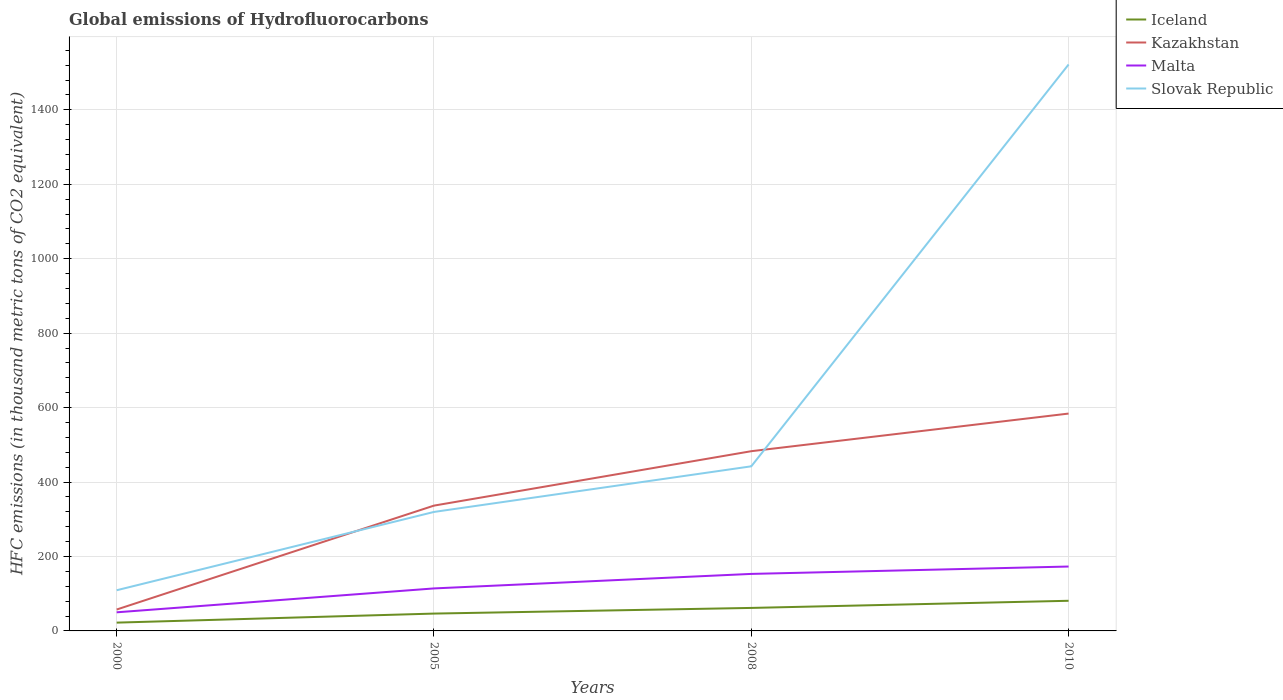Is the number of lines equal to the number of legend labels?
Give a very brief answer. Yes. Across all years, what is the maximum global emissions of Hydrofluorocarbons in Slovak Republic?
Your answer should be very brief. 109.3. What is the total global emissions of Hydrofluorocarbons in Malta in the graph?
Your answer should be compact. -39. What is the difference between the highest and the second highest global emissions of Hydrofluorocarbons in Malta?
Ensure brevity in your answer.  123. What is the difference between the highest and the lowest global emissions of Hydrofluorocarbons in Malta?
Make the answer very short. 2. How many lines are there?
Your answer should be very brief. 4. How many years are there in the graph?
Offer a terse response. 4. What is the difference between two consecutive major ticks on the Y-axis?
Your answer should be compact. 200. Are the values on the major ticks of Y-axis written in scientific E-notation?
Give a very brief answer. No. Where does the legend appear in the graph?
Give a very brief answer. Top right. How many legend labels are there?
Provide a short and direct response. 4. What is the title of the graph?
Offer a terse response. Global emissions of Hydrofluorocarbons. What is the label or title of the X-axis?
Your answer should be compact. Years. What is the label or title of the Y-axis?
Provide a succinct answer. HFC emissions (in thousand metric tons of CO2 equivalent). What is the HFC emissions (in thousand metric tons of CO2 equivalent) in Iceland in 2000?
Your answer should be compact. 22.3. What is the HFC emissions (in thousand metric tons of CO2 equivalent) of Kazakhstan in 2000?
Offer a terse response. 57.5. What is the HFC emissions (in thousand metric tons of CO2 equivalent) in Malta in 2000?
Offer a terse response. 50. What is the HFC emissions (in thousand metric tons of CO2 equivalent) in Slovak Republic in 2000?
Give a very brief answer. 109.3. What is the HFC emissions (in thousand metric tons of CO2 equivalent) of Iceland in 2005?
Offer a terse response. 46.6. What is the HFC emissions (in thousand metric tons of CO2 equivalent) in Kazakhstan in 2005?
Offer a terse response. 336.7. What is the HFC emissions (in thousand metric tons of CO2 equivalent) in Malta in 2005?
Your response must be concise. 114.2. What is the HFC emissions (in thousand metric tons of CO2 equivalent) of Slovak Republic in 2005?
Your answer should be compact. 319.7. What is the HFC emissions (in thousand metric tons of CO2 equivalent) in Iceland in 2008?
Make the answer very short. 61.8. What is the HFC emissions (in thousand metric tons of CO2 equivalent) of Kazakhstan in 2008?
Give a very brief answer. 482.9. What is the HFC emissions (in thousand metric tons of CO2 equivalent) of Malta in 2008?
Your answer should be very brief. 153.2. What is the HFC emissions (in thousand metric tons of CO2 equivalent) of Slovak Republic in 2008?
Provide a succinct answer. 442.3. What is the HFC emissions (in thousand metric tons of CO2 equivalent) in Kazakhstan in 2010?
Provide a short and direct response. 584. What is the HFC emissions (in thousand metric tons of CO2 equivalent) in Malta in 2010?
Offer a terse response. 173. What is the HFC emissions (in thousand metric tons of CO2 equivalent) of Slovak Republic in 2010?
Offer a terse response. 1522. Across all years, what is the maximum HFC emissions (in thousand metric tons of CO2 equivalent) in Kazakhstan?
Offer a very short reply. 584. Across all years, what is the maximum HFC emissions (in thousand metric tons of CO2 equivalent) of Malta?
Provide a succinct answer. 173. Across all years, what is the maximum HFC emissions (in thousand metric tons of CO2 equivalent) in Slovak Republic?
Your answer should be compact. 1522. Across all years, what is the minimum HFC emissions (in thousand metric tons of CO2 equivalent) in Iceland?
Make the answer very short. 22.3. Across all years, what is the minimum HFC emissions (in thousand metric tons of CO2 equivalent) of Kazakhstan?
Provide a succinct answer. 57.5. Across all years, what is the minimum HFC emissions (in thousand metric tons of CO2 equivalent) in Malta?
Provide a succinct answer. 50. Across all years, what is the minimum HFC emissions (in thousand metric tons of CO2 equivalent) in Slovak Republic?
Keep it short and to the point. 109.3. What is the total HFC emissions (in thousand metric tons of CO2 equivalent) in Iceland in the graph?
Your answer should be compact. 211.7. What is the total HFC emissions (in thousand metric tons of CO2 equivalent) of Kazakhstan in the graph?
Keep it short and to the point. 1461.1. What is the total HFC emissions (in thousand metric tons of CO2 equivalent) of Malta in the graph?
Your answer should be compact. 490.4. What is the total HFC emissions (in thousand metric tons of CO2 equivalent) of Slovak Republic in the graph?
Make the answer very short. 2393.3. What is the difference between the HFC emissions (in thousand metric tons of CO2 equivalent) in Iceland in 2000 and that in 2005?
Offer a terse response. -24.3. What is the difference between the HFC emissions (in thousand metric tons of CO2 equivalent) in Kazakhstan in 2000 and that in 2005?
Offer a very short reply. -279.2. What is the difference between the HFC emissions (in thousand metric tons of CO2 equivalent) of Malta in 2000 and that in 2005?
Your answer should be compact. -64.2. What is the difference between the HFC emissions (in thousand metric tons of CO2 equivalent) in Slovak Republic in 2000 and that in 2005?
Your answer should be very brief. -210.4. What is the difference between the HFC emissions (in thousand metric tons of CO2 equivalent) of Iceland in 2000 and that in 2008?
Your answer should be very brief. -39.5. What is the difference between the HFC emissions (in thousand metric tons of CO2 equivalent) of Kazakhstan in 2000 and that in 2008?
Offer a terse response. -425.4. What is the difference between the HFC emissions (in thousand metric tons of CO2 equivalent) of Malta in 2000 and that in 2008?
Keep it short and to the point. -103.2. What is the difference between the HFC emissions (in thousand metric tons of CO2 equivalent) in Slovak Republic in 2000 and that in 2008?
Provide a succinct answer. -333. What is the difference between the HFC emissions (in thousand metric tons of CO2 equivalent) of Iceland in 2000 and that in 2010?
Your answer should be very brief. -58.7. What is the difference between the HFC emissions (in thousand metric tons of CO2 equivalent) in Kazakhstan in 2000 and that in 2010?
Keep it short and to the point. -526.5. What is the difference between the HFC emissions (in thousand metric tons of CO2 equivalent) in Malta in 2000 and that in 2010?
Keep it short and to the point. -123. What is the difference between the HFC emissions (in thousand metric tons of CO2 equivalent) of Slovak Republic in 2000 and that in 2010?
Give a very brief answer. -1412.7. What is the difference between the HFC emissions (in thousand metric tons of CO2 equivalent) of Iceland in 2005 and that in 2008?
Keep it short and to the point. -15.2. What is the difference between the HFC emissions (in thousand metric tons of CO2 equivalent) of Kazakhstan in 2005 and that in 2008?
Offer a terse response. -146.2. What is the difference between the HFC emissions (in thousand metric tons of CO2 equivalent) of Malta in 2005 and that in 2008?
Offer a terse response. -39. What is the difference between the HFC emissions (in thousand metric tons of CO2 equivalent) in Slovak Republic in 2005 and that in 2008?
Give a very brief answer. -122.6. What is the difference between the HFC emissions (in thousand metric tons of CO2 equivalent) of Iceland in 2005 and that in 2010?
Offer a terse response. -34.4. What is the difference between the HFC emissions (in thousand metric tons of CO2 equivalent) in Kazakhstan in 2005 and that in 2010?
Make the answer very short. -247.3. What is the difference between the HFC emissions (in thousand metric tons of CO2 equivalent) of Malta in 2005 and that in 2010?
Keep it short and to the point. -58.8. What is the difference between the HFC emissions (in thousand metric tons of CO2 equivalent) in Slovak Republic in 2005 and that in 2010?
Provide a short and direct response. -1202.3. What is the difference between the HFC emissions (in thousand metric tons of CO2 equivalent) of Iceland in 2008 and that in 2010?
Provide a succinct answer. -19.2. What is the difference between the HFC emissions (in thousand metric tons of CO2 equivalent) of Kazakhstan in 2008 and that in 2010?
Keep it short and to the point. -101.1. What is the difference between the HFC emissions (in thousand metric tons of CO2 equivalent) of Malta in 2008 and that in 2010?
Keep it short and to the point. -19.8. What is the difference between the HFC emissions (in thousand metric tons of CO2 equivalent) in Slovak Republic in 2008 and that in 2010?
Ensure brevity in your answer.  -1079.7. What is the difference between the HFC emissions (in thousand metric tons of CO2 equivalent) of Iceland in 2000 and the HFC emissions (in thousand metric tons of CO2 equivalent) of Kazakhstan in 2005?
Your answer should be very brief. -314.4. What is the difference between the HFC emissions (in thousand metric tons of CO2 equivalent) of Iceland in 2000 and the HFC emissions (in thousand metric tons of CO2 equivalent) of Malta in 2005?
Your answer should be very brief. -91.9. What is the difference between the HFC emissions (in thousand metric tons of CO2 equivalent) in Iceland in 2000 and the HFC emissions (in thousand metric tons of CO2 equivalent) in Slovak Republic in 2005?
Provide a succinct answer. -297.4. What is the difference between the HFC emissions (in thousand metric tons of CO2 equivalent) in Kazakhstan in 2000 and the HFC emissions (in thousand metric tons of CO2 equivalent) in Malta in 2005?
Ensure brevity in your answer.  -56.7. What is the difference between the HFC emissions (in thousand metric tons of CO2 equivalent) of Kazakhstan in 2000 and the HFC emissions (in thousand metric tons of CO2 equivalent) of Slovak Republic in 2005?
Ensure brevity in your answer.  -262.2. What is the difference between the HFC emissions (in thousand metric tons of CO2 equivalent) in Malta in 2000 and the HFC emissions (in thousand metric tons of CO2 equivalent) in Slovak Republic in 2005?
Keep it short and to the point. -269.7. What is the difference between the HFC emissions (in thousand metric tons of CO2 equivalent) in Iceland in 2000 and the HFC emissions (in thousand metric tons of CO2 equivalent) in Kazakhstan in 2008?
Make the answer very short. -460.6. What is the difference between the HFC emissions (in thousand metric tons of CO2 equivalent) of Iceland in 2000 and the HFC emissions (in thousand metric tons of CO2 equivalent) of Malta in 2008?
Your answer should be very brief. -130.9. What is the difference between the HFC emissions (in thousand metric tons of CO2 equivalent) in Iceland in 2000 and the HFC emissions (in thousand metric tons of CO2 equivalent) in Slovak Republic in 2008?
Provide a short and direct response. -420. What is the difference between the HFC emissions (in thousand metric tons of CO2 equivalent) in Kazakhstan in 2000 and the HFC emissions (in thousand metric tons of CO2 equivalent) in Malta in 2008?
Give a very brief answer. -95.7. What is the difference between the HFC emissions (in thousand metric tons of CO2 equivalent) in Kazakhstan in 2000 and the HFC emissions (in thousand metric tons of CO2 equivalent) in Slovak Republic in 2008?
Make the answer very short. -384.8. What is the difference between the HFC emissions (in thousand metric tons of CO2 equivalent) in Malta in 2000 and the HFC emissions (in thousand metric tons of CO2 equivalent) in Slovak Republic in 2008?
Keep it short and to the point. -392.3. What is the difference between the HFC emissions (in thousand metric tons of CO2 equivalent) in Iceland in 2000 and the HFC emissions (in thousand metric tons of CO2 equivalent) in Kazakhstan in 2010?
Make the answer very short. -561.7. What is the difference between the HFC emissions (in thousand metric tons of CO2 equivalent) in Iceland in 2000 and the HFC emissions (in thousand metric tons of CO2 equivalent) in Malta in 2010?
Give a very brief answer. -150.7. What is the difference between the HFC emissions (in thousand metric tons of CO2 equivalent) of Iceland in 2000 and the HFC emissions (in thousand metric tons of CO2 equivalent) of Slovak Republic in 2010?
Keep it short and to the point. -1499.7. What is the difference between the HFC emissions (in thousand metric tons of CO2 equivalent) of Kazakhstan in 2000 and the HFC emissions (in thousand metric tons of CO2 equivalent) of Malta in 2010?
Provide a succinct answer. -115.5. What is the difference between the HFC emissions (in thousand metric tons of CO2 equivalent) of Kazakhstan in 2000 and the HFC emissions (in thousand metric tons of CO2 equivalent) of Slovak Republic in 2010?
Give a very brief answer. -1464.5. What is the difference between the HFC emissions (in thousand metric tons of CO2 equivalent) in Malta in 2000 and the HFC emissions (in thousand metric tons of CO2 equivalent) in Slovak Republic in 2010?
Keep it short and to the point. -1472. What is the difference between the HFC emissions (in thousand metric tons of CO2 equivalent) in Iceland in 2005 and the HFC emissions (in thousand metric tons of CO2 equivalent) in Kazakhstan in 2008?
Your answer should be very brief. -436.3. What is the difference between the HFC emissions (in thousand metric tons of CO2 equivalent) of Iceland in 2005 and the HFC emissions (in thousand metric tons of CO2 equivalent) of Malta in 2008?
Provide a short and direct response. -106.6. What is the difference between the HFC emissions (in thousand metric tons of CO2 equivalent) of Iceland in 2005 and the HFC emissions (in thousand metric tons of CO2 equivalent) of Slovak Republic in 2008?
Give a very brief answer. -395.7. What is the difference between the HFC emissions (in thousand metric tons of CO2 equivalent) of Kazakhstan in 2005 and the HFC emissions (in thousand metric tons of CO2 equivalent) of Malta in 2008?
Offer a terse response. 183.5. What is the difference between the HFC emissions (in thousand metric tons of CO2 equivalent) in Kazakhstan in 2005 and the HFC emissions (in thousand metric tons of CO2 equivalent) in Slovak Republic in 2008?
Keep it short and to the point. -105.6. What is the difference between the HFC emissions (in thousand metric tons of CO2 equivalent) in Malta in 2005 and the HFC emissions (in thousand metric tons of CO2 equivalent) in Slovak Republic in 2008?
Provide a succinct answer. -328.1. What is the difference between the HFC emissions (in thousand metric tons of CO2 equivalent) in Iceland in 2005 and the HFC emissions (in thousand metric tons of CO2 equivalent) in Kazakhstan in 2010?
Make the answer very short. -537.4. What is the difference between the HFC emissions (in thousand metric tons of CO2 equivalent) in Iceland in 2005 and the HFC emissions (in thousand metric tons of CO2 equivalent) in Malta in 2010?
Provide a succinct answer. -126.4. What is the difference between the HFC emissions (in thousand metric tons of CO2 equivalent) of Iceland in 2005 and the HFC emissions (in thousand metric tons of CO2 equivalent) of Slovak Republic in 2010?
Your answer should be very brief. -1475.4. What is the difference between the HFC emissions (in thousand metric tons of CO2 equivalent) in Kazakhstan in 2005 and the HFC emissions (in thousand metric tons of CO2 equivalent) in Malta in 2010?
Provide a short and direct response. 163.7. What is the difference between the HFC emissions (in thousand metric tons of CO2 equivalent) in Kazakhstan in 2005 and the HFC emissions (in thousand metric tons of CO2 equivalent) in Slovak Republic in 2010?
Offer a terse response. -1185.3. What is the difference between the HFC emissions (in thousand metric tons of CO2 equivalent) of Malta in 2005 and the HFC emissions (in thousand metric tons of CO2 equivalent) of Slovak Republic in 2010?
Give a very brief answer. -1407.8. What is the difference between the HFC emissions (in thousand metric tons of CO2 equivalent) of Iceland in 2008 and the HFC emissions (in thousand metric tons of CO2 equivalent) of Kazakhstan in 2010?
Give a very brief answer. -522.2. What is the difference between the HFC emissions (in thousand metric tons of CO2 equivalent) in Iceland in 2008 and the HFC emissions (in thousand metric tons of CO2 equivalent) in Malta in 2010?
Provide a succinct answer. -111.2. What is the difference between the HFC emissions (in thousand metric tons of CO2 equivalent) of Iceland in 2008 and the HFC emissions (in thousand metric tons of CO2 equivalent) of Slovak Republic in 2010?
Your response must be concise. -1460.2. What is the difference between the HFC emissions (in thousand metric tons of CO2 equivalent) of Kazakhstan in 2008 and the HFC emissions (in thousand metric tons of CO2 equivalent) of Malta in 2010?
Offer a terse response. 309.9. What is the difference between the HFC emissions (in thousand metric tons of CO2 equivalent) in Kazakhstan in 2008 and the HFC emissions (in thousand metric tons of CO2 equivalent) in Slovak Republic in 2010?
Make the answer very short. -1039.1. What is the difference between the HFC emissions (in thousand metric tons of CO2 equivalent) of Malta in 2008 and the HFC emissions (in thousand metric tons of CO2 equivalent) of Slovak Republic in 2010?
Provide a short and direct response. -1368.8. What is the average HFC emissions (in thousand metric tons of CO2 equivalent) in Iceland per year?
Offer a very short reply. 52.92. What is the average HFC emissions (in thousand metric tons of CO2 equivalent) in Kazakhstan per year?
Your response must be concise. 365.27. What is the average HFC emissions (in thousand metric tons of CO2 equivalent) in Malta per year?
Ensure brevity in your answer.  122.6. What is the average HFC emissions (in thousand metric tons of CO2 equivalent) of Slovak Republic per year?
Provide a short and direct response. 598.33. In the year 2000, what is the difference between the HFC emissions (in thousand metric tons of CO2 equivalent) of Iceland and HFC emissions (in thousand metric tons of CO2 equivalent) of Kazakhstan?
Provide a short and direct response. -35.2. In the year 2000, what is the difference between the HFC emissions (in thousand metric tons of CO2 equivalent) in Iceland and HFC emissions (in thousand metric tons of CO2 equivalent) in Malta?
Your response must be concise. -27.7. In the year 2000, what is the difference between the HFC emissions (in thousand metric tons of CO2 equivalent) of Iceland and HFC emissions (in thousand metric tons of CO2 equivalent) of Slovak Republic?
Your response must be concise. -87. In the year 2000, what is the difference between the HFC emissions (in thousand metric tons of CO2 equivalent) of Kazakhstan and HFC emissions (in thousand metric tons of CO2 equivalent) of Slovak Republic?
Your response must be concise. -51.8. In the year 2000, what is the difference between the HFC emissions (in thousand metric tons of CO2 equivalent) of Malta and HFC emissions (in thousand metric tons of CO2 equivalent) of Slovak Republic?
Your response must be concise. -59.3. In the year 2005, what is the difference between the HFC emissions (in thousand metric tons of CO2 equivalent) in Iceland and HFC emissions (in thousand metric tons of CO2 equivalent) in Kazakhstan?
Your answer should be very brief. -290.1. In the year 2005, what is the difference between the HFC emissions (in thousand metric tons of CO2 equivalent) of Iceland and HFC emissions (in thousand metric tons of CO2 equivalent) of Malta?
Make the answer very short. -67.6. In the year 2005, what is the difference between the HFC emissions (in thousand metric tons of CO2 equivalent) of Iceland and HFC emissions (in thousand metric tons of CO2 equivalent) of Slovak Republic?
Your response must be concise. -273.1. In the year 2005, what is the difference between the HFC emissions (in thousand metric tons of CO2 equivalent) in Kazakhstan and HFC emissions (in thousand metric tons of CO2 equivalent) in Malta?
Offer a very short reply. 222.5. In the year 2005, what is the difference between the HFC emissions (in thousand metric tons of CO2 equivalent) of Malta and HFC emissions (in thousand metric tons of CO2 equivalent) of Slovak Republic?
Provide a short and direct response. -205.5. In the year 2008, what is the difference between the HFC emissions (in thousand metric tons of CO2 equivalent) of Iceland and HFC emissions (in thousand metric tons of CO2 equivalent) of Kazakhstan?
Offer a very short reply. -421.1. In the year 2008, what is the difference between the HFC emissions (in thousand metric tons of CO2 equivalent) in Iceland and HFC emissions (in thousand metric tons of CO2 equivalent) in Malta?
Ensure brevity in your answer.  -91.4. In the year 2008, what is the difference between the HFC emissions (in thousand metric tons of CO2 equivalent) in Iceland and HFC emissions (in thousand metric tons of CO2 equivalent) in Slovak Republic?
Your response must be concise. -380.5. In the year 2008, what is the difference between the HFC emissions (in thousand metric tons of CO2 equivalent) in Kazakhstan and HFC emissions (in thousand metric tons of CO2 equivalent) in Malta?
Your answer should be compact. 329.7. In the year 2008, what is the difference between the HFC emissions (in thousand metric tons of CO2 equivalent) of Kazakhstan and HFC emissions (in thousand metric tons of CO2 equivalent) of Slovak Republic?
Make the answer very short. 40.6. In the year 2008, what is the difference between the HFC emissions (in thousand metric tons of CO2 equivalent) in Malta and HFC emissions (in thousand metric tons of CO2 equivalent) in Slovak Republic?
Your answer should be compact. -289.1. In the year 2010, what is the difference between the HFC emissions (in thousand metric tons of CO2 equivalent) of Iceland and HFC emissions (in thousand metric tons of CO2 equivalent) of Kazakhstan?
Make the answer very short. -503. In the year 2010, what is the difference between the HFC emissions (in thousand metric tons of CO2 equivalent) of Iceland and HFC emissions (in thousand metric tons of CO2 equivalent) of Malta?
Keep it short and to the point. -92. In the year 2010, what is the difference between the HFC emissions (in thousand metric tons of CO2 equivalent) in Iceland and HFC emissions (in thousand metric tons of CO2 equivalent) in Slovak Republic?
Provide a succinct answer. -1441. In the year 2010, what is the difference between the HFC emissions (in thousand metric tons of CO2 equivalent) in Kazakhstan and HFC emissions (in thousand metric tons of CO2 equivalent) in Malta?
Offer a very short reply. 411. In the year 2010, what is the difference between the HFC emissions (in thousand metric tons of CO2 equivalent) in Kazakhstan and HFC emissions (in thousand metric tons of CO2 equivalent) in Slovak Republic?
Provide a succinct answer. -938. In the year 2010, what is the difference between the HFC emissions (in thousand metric tons of CO2 equivalent) of Malta and HFC emissions (in thousand metric tons of CO2 equivalent) of Slovak Republic?
Ensure brevity in your answer.  -1349. What is the ratio of the HFC emissions (in thousand metric tons of CO2 equivalent) in Iceland in 2000 to that in 2005?
Your answer should be very brief. 0.48. What is the ratio of the HFC emissions (in thousand metric tons of CO2 equivalent) of Kazakhstan in 2000 to that in 2005?
Your answer should be compact. 0.17. What is the ratio of the HFC emissions (in thousand metric tons of CO2 equivalent) in Malta in 2000 to that in 2005?
Offer a very short reply. 0.44. What is the ratio of the HFC emissions (in thousand metric tons of CO2 equivalent) in Slovak Republic in 2000 to that in 2005?
Ensure brevity in your answer.  0.34. What is the ratio of the HFC emissions (in thousand metric tons of CO2 equivalent) of Iceland in 2000 to that in 2008?
Give a very brief answer. 0.36. What is the ratio of the HFC emissions (in thousand metric tons of CO2 equivalent) of Kazakhstan in 2000 to that in 2008?
Provide a short and direct response. 0.12. What is the ratio of the HFC emissions (in thousand metric tons of CO2 equivalent) in Malta in 2000 to that in 2008?
Your answer should be very brief. 0.33. What is the ratio of the HFC emissions (in thousand metric tons of CO2 equivalent) in Slovak Republic in 2000 to that in 2008?
Provide a short and direct response. 0.25. What is the ratio of the HFC emissions (in thousand metric tons of CO2 equivalent) of Iceland in 2000 to that in 2010?
Provide a succinct answer. 0.28. What is the ratio of the HFC emissions (in thousand metric tons of CO2 equivalent) in Kazakhstan in 2000 to that in 2010?
Your answer should be compact. 0.1. What is the ratio of the HFC emissions (in thousand metric tons of CO2 equivalent) of Malta in 2000 to that in 2010?
Provide a succinct answer. 0.29. What is the ratio of the HFC emissions (in thousand metric tons of CO2 equivalent) of Slovak Republic in 2000 to that in 2010?
Keep it short and to the point. 0.07. What is the ratio of the HFC emissions (in thousand metric tons of CO2 equivalent) in Iceland in 2005 to that in 2008?
Offer a very short reply. 0.75. What is the ratio of the HFC emissions (in thousand metric tons of CO2 equivalent) in Kazakhstan in 2005 to that in 2008?
Your answer should be compact. 0.7. What is the ratio of the HFC emissions (in thousand metric tons of CO2 equivalent) of Malta in 2005 to that in 2008?
Make the answer very short. 0.75. What is the ratio of the HFC emissions (in thousand metric tons of CO2 equivalent) in Slovak Republic in 2005 to that in 2008?
Keep it short and to the point. 0.72. What is the ratio of the HFC emissions (in thousand metric tons of CO2 equivalent) in Iceland in 2005 to that in 2010?
Ensure brevity in your answer.  0.58. What is the ratio of the HFC emissions (in thousand metric tons of CO2 equivalent) of Kazakhstan in 2005 to that in 2010?
Provide a succinct answer. 0.58. What is the ratio of the HFC emissions (in thousand metric tons of CO2 equivalent) of Malta in 2005 to that in 2010?
Your answer should be compact. 0.66. What is the ratio of the HFC emissions (in thousand metric tons of CO2 equivalent) of Slovak Republic in 2005 to that in 2010?
Your answer should be very brief. 0.21. What is the ratio of the HFC emissions (in thousand metric tons of CO2 equivalent) in Iceland in 2008 to that in 2010?
Your response must be concise. 0.76. What is the ratio of the HFC emissions (in thousand metric tons of CO2 equivalent) in Kazakhstan in 2008 to that in 2010?
Provide a succinct answer. 0.83. What is the ratio of the HFC emissions (in thousand metric tons of CO2 equivalent) of Malta in 2008 to that in 2010?
Ensure brevity in your answer.  0.89. What is the ratio of the HFC emissions (in thousand metric tons of CO2 equivalent) of Slovak Republic in 2008 to that in 2010?
Keep it short and to the point. 0.29. What is the difference between the highest and the second highest HFC emissions (in thousand metric tons of CO2 equivalent) in Kazakhstan?
Provide a short and direct response. 101.1. What is the difference between the highest and the second highest HFC emissions (in thousand metric tons of CO2 equivalent) of Malta?
Ensure brevity in your answer.  19.8. What is the difference between the highest and the second highest HFC emissions (in thousand metric tons of CO2 equivalent) of Slovak Republic?
Your answer should be very brief. 1079.7. What is the difference between the highest and the lowest HFC emissions (in thousand metric tons of CO2 equivalent) in Iceland?
Offer a very short reply. 58.7. What is the difference between the highest and the lowest HFC emissions (in thousand metric tons of CO2 equivalent) in Kazakhstan?
Provide a short and direct response. 526.5. What is the difference between the highest and the lowest HFC emissions (in thousand metric tons of CO2 equivalent) of Malta?
Provide a short and direct response. 123. What is the difference between the highest and the lowest HFC emissions (in thousand metric tons of CO2 equivalent) in Slovak Republic?
Offer a very short reply. 1412.7. 